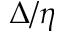Convert formula to latex. <formula><loc_0><loc_0><loc_500><loc_500>\Delta / \eta</formula> 